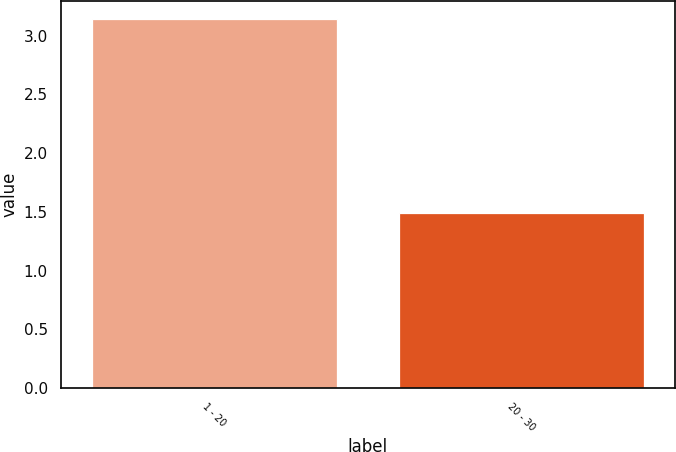<chart> <loc_0><loc_0><loc_500><loc_500><bar_chart><fcel>1 - 20<fcel>20 - 30<nl><fcel>3.14<fcel>1.49<nl></chart> 